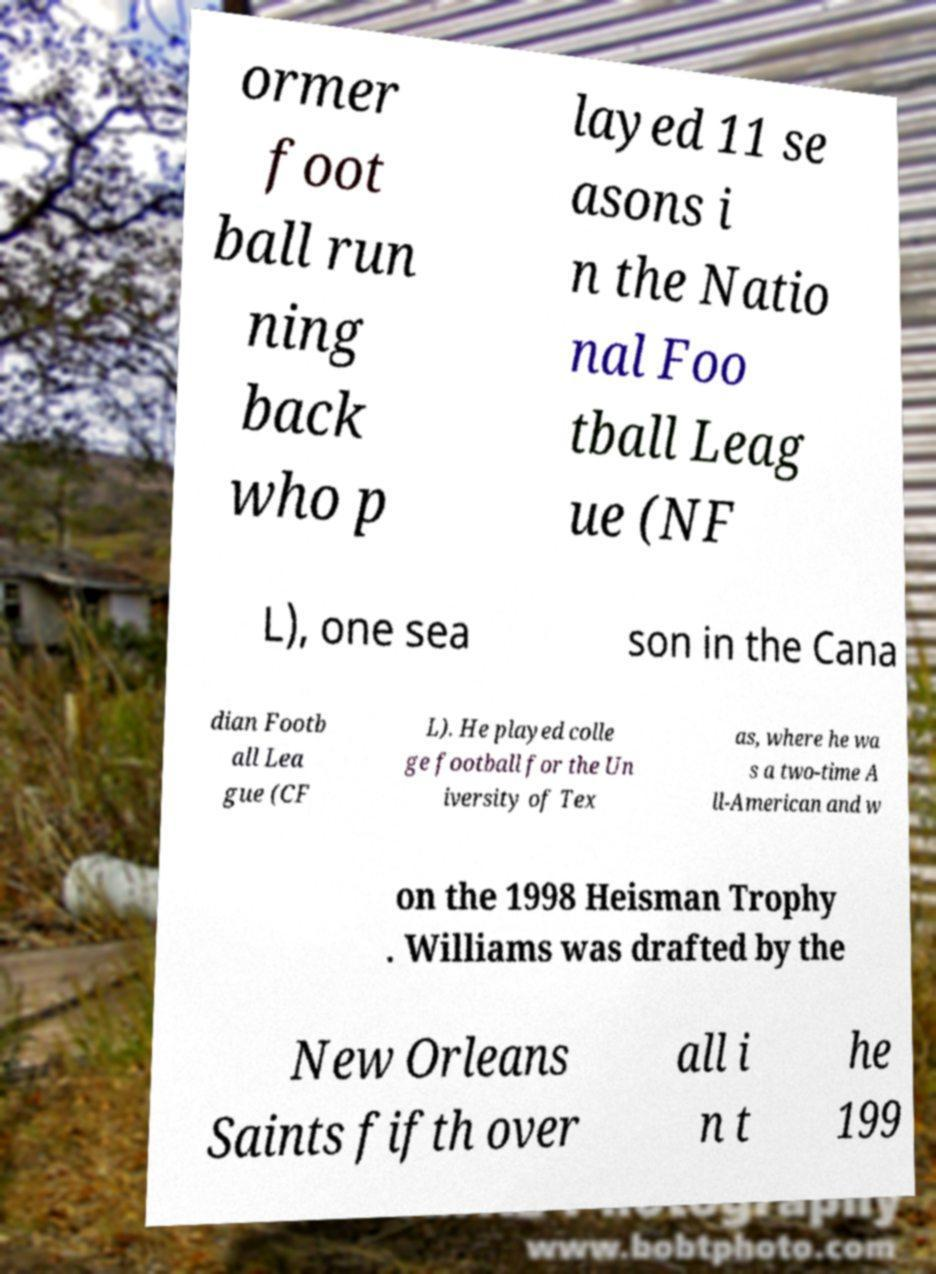I need the written content from this picture converted into text. Can you do that? ormer foot ball run ning back who p layed 11 se asons i n the Natio nal Foo tball Leag ue (NF L), one sea son in the Cana dian Footb all Lea gue (CF L). He played colle ge football for the Un iversity of Tex as, where he wa s a two-time A ll-American and w on the 1998 Heisman Trophy . Williams was drafted by the New Orleans Saints fifth over all i n t he 199 